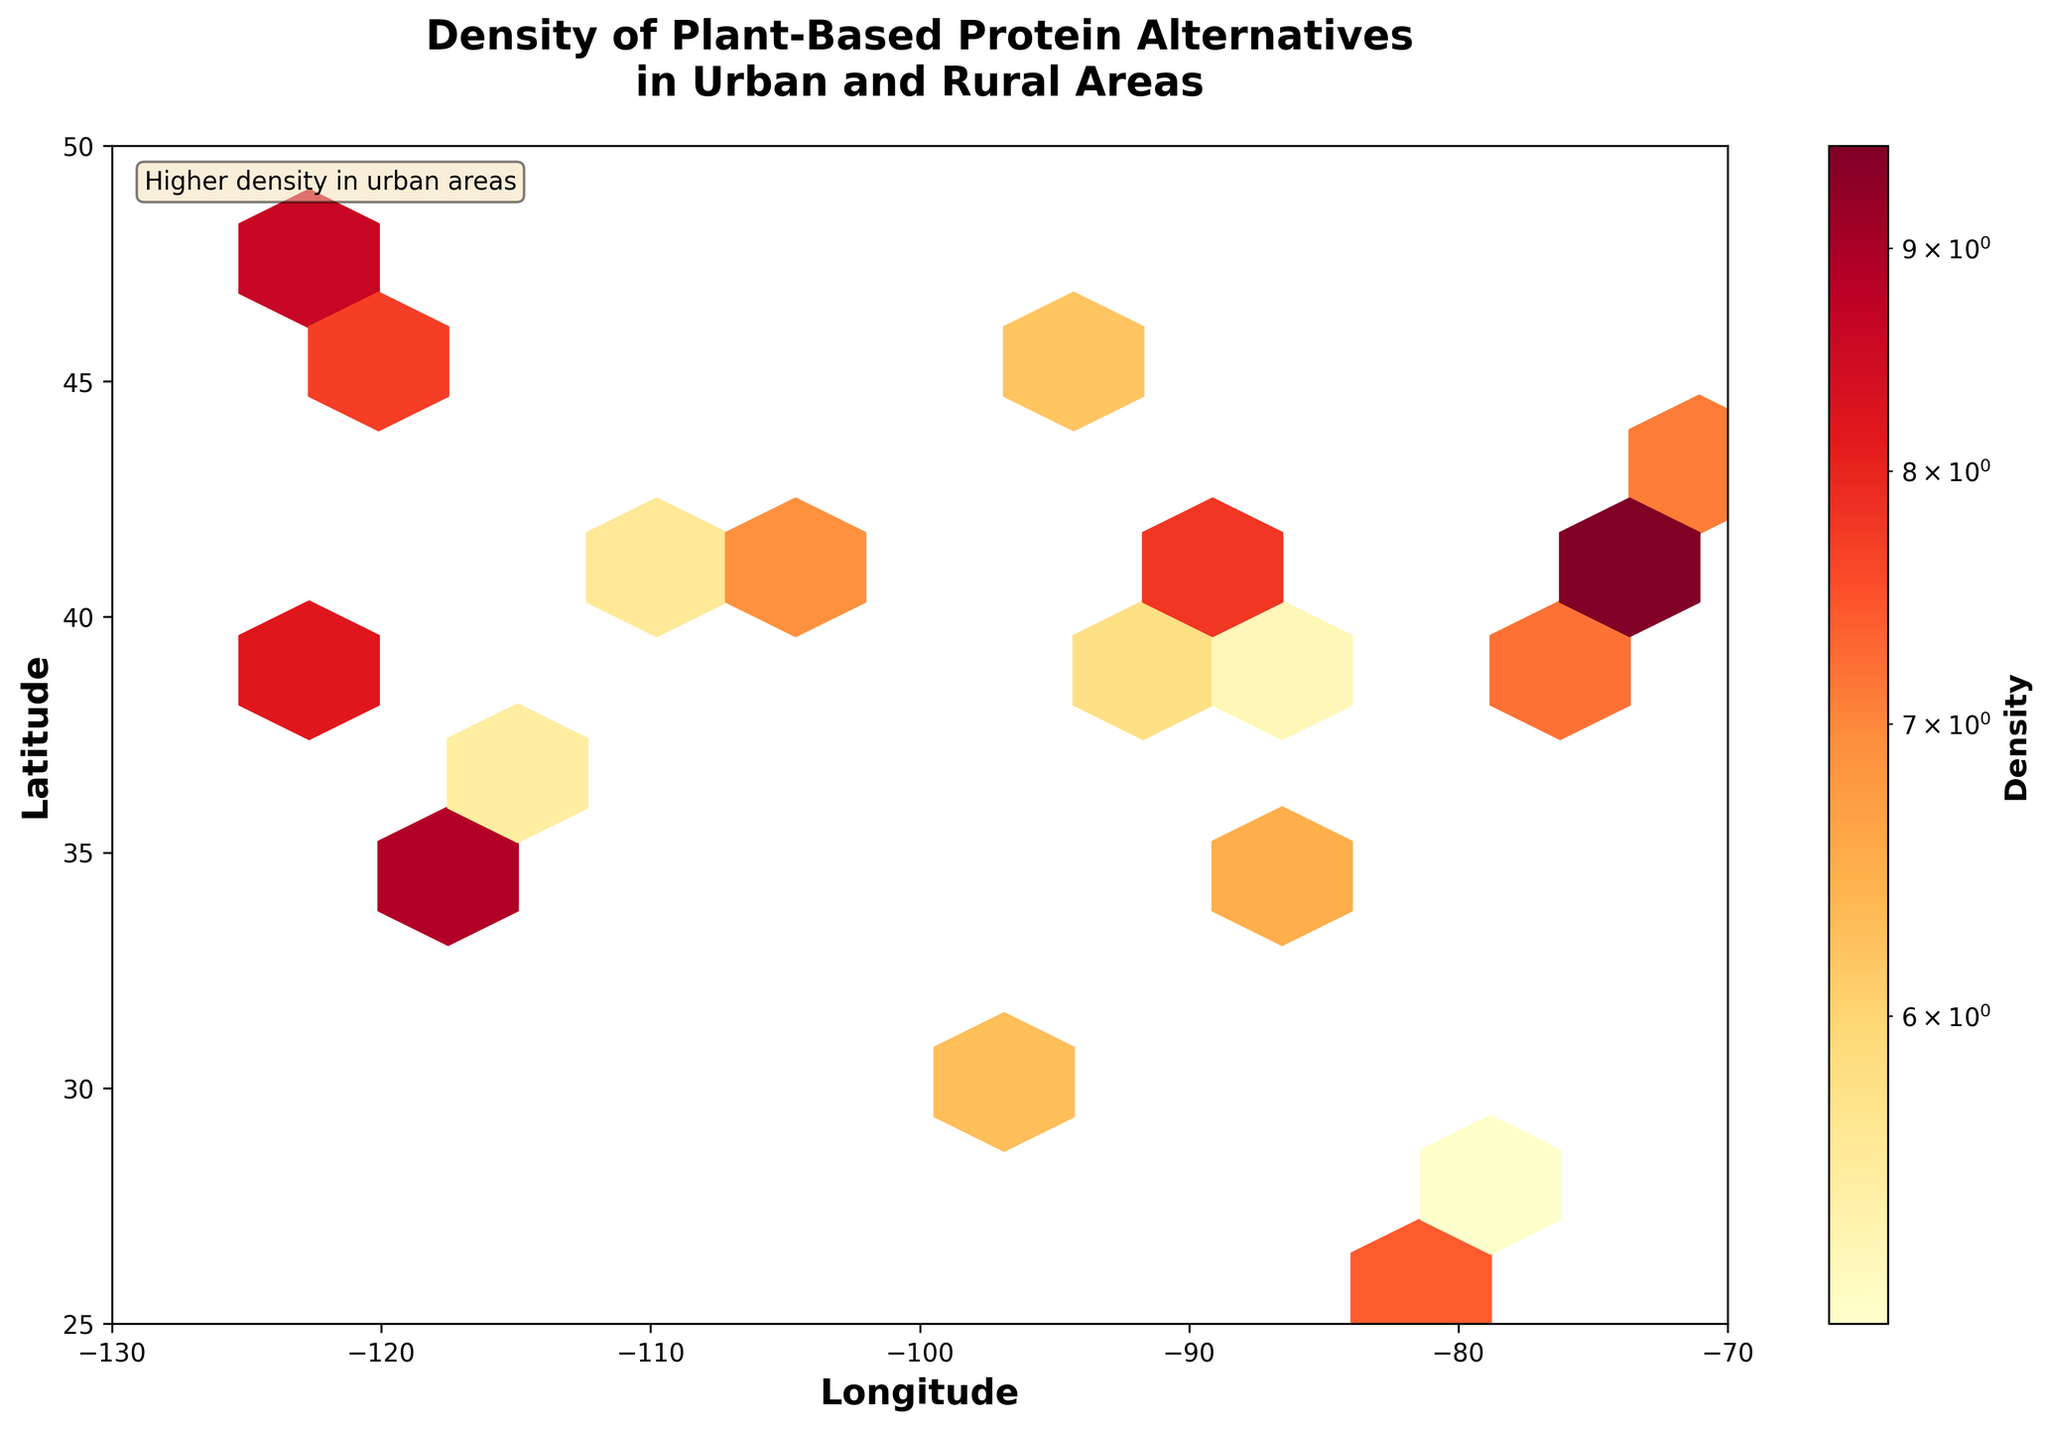What is the title of the plot? The title of the plot is located at the top center of the figure and summarizes what the plot represents. It reads "Density of Plant-Based Protein Alternatives in Urban and Rural Areas".
Answer: Density of Plant-Based Protein Alternatives in Urban and Rural Areas What do the x and y-axes represent? The x and y-axes are labeled "Longitude" and "Latitude" respectively, indicating that the plot shows geographical coordinates where data was collected.
Answer: Longitude and Latitude What color represents higher density in the hexbin plot? The color bar to the right of the plot, moving from lighter yellow to dark red, indicates that darker red areas represent higher densities of plant-based protein alternatives.
Answer: Dark red How many data points are shown in the hexbin plot? To determine the number of data points, count the number of hexagonal bins that are filled with color. Each hexagon represents one or more data points. The exact number is not directly shown but inference suggests the plot is filled with colored hexagons.
Answer: Number varies but corresponds to filled hexagons Which areas have higher densities of plant-based protein alternatives? Areas with darker red hues on the hexbin plot have higher densities of plant-based protein alternatives. These regions are generally located around major urban areas as inferred from their coordinates.
Answer: Major urban areas What is the density value at the coordinates 40.7128, -74.0060? By matching the given latitude and longitude with the spatial region on the hexbin plot and then referencing the color, we can see the density is represented by 9.5.
Answer: 9.5 Are plant-based protein alternatives more densely present in urban or rural areas? By observing the hexbin plot, the higher density (darker colors) is concentrated mostly in urban areas, indicating a higher density in these regions compared to rural ones.
Answer: Urban areas How does the density of plant-based protein alternatives in San Francisco compare to that in Miami? San Francisco (37.7749, -122.4194) shows a density of 8.2, whereas Miami (25.7617, -80.1918) shows a density of 7.4. Thus, San Francisco has a higher density than Miami.
Answer: San Francisco is higher What does the hexagonal bin size represent and how does it affect the plot? The hexagonal bin size (gridsize=10) determines the spatial resolution of the plot. Smaller hexagons support finer spatial resolution, revealing more granular detail, while larger hexagons can obscure specific dense areas.
Answer: Spatial resolution and detail What is stated in the text box within the plot? The text box located at the top left of the plot states "Higher density in urban areas," providing a specific insight into the data visualization.
Answer: Higher density in urban areas 